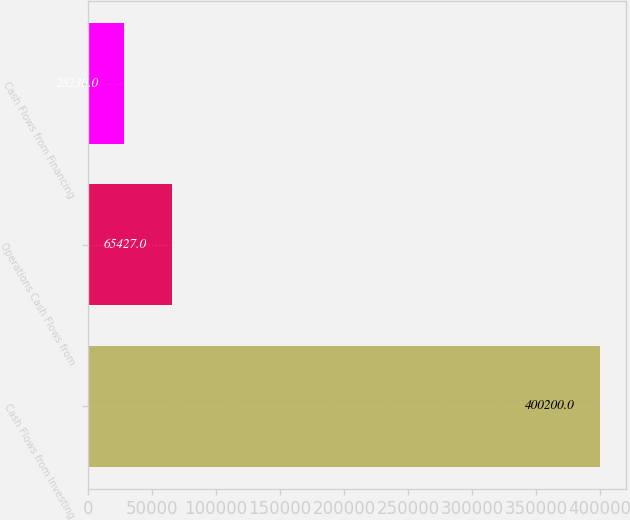Convert chart. <chart><loc_0><loc_0><loc_500><loc_500><bar_chart><fcel>Cash Flows from Investing<fcel>Operations Cash Flows from<fcel>Cash Flows from Financing<nl><fcel>400200<fcel>65427<fcel>28230<nl></chart> 